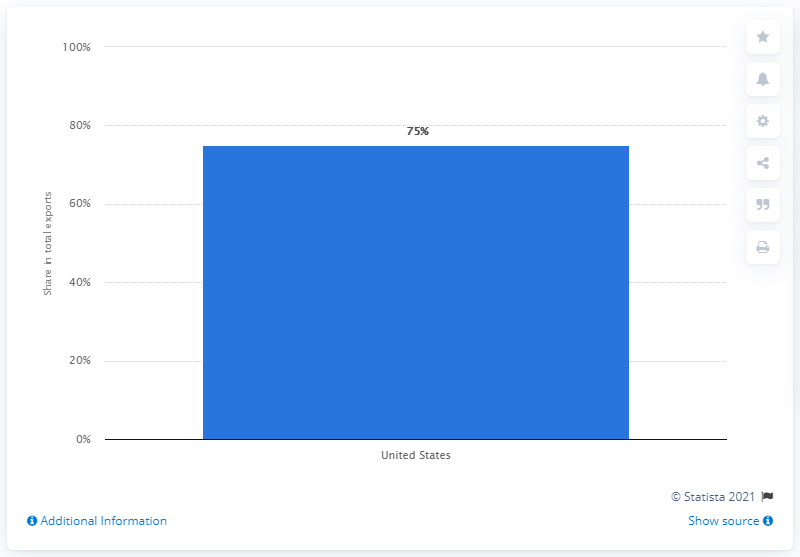List a handful of essential elements in this visual. In 2019, the United States was Mexico's primary export partner, accounting for the majority of the country's exported goods. 